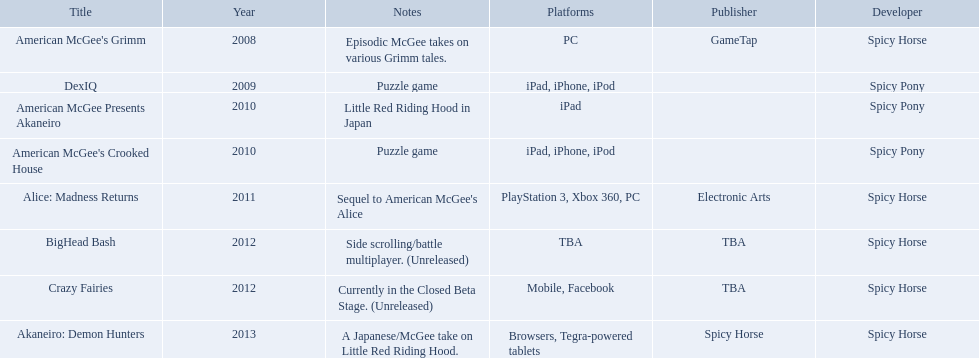Which spicy horse titles are shown? American McGee's Grimm, DexIQ, American McGee Presents Akaneiro, American McGee's Crooked House, Alice: Madness Returns, BigHead Bash, Crazy Fairies, Akaneiro: Demon Hunters. Of those, which are for the ipad? DexIQ, American McGee Presents Akaneiro, American McGee's Crooked House. Which of those are not for the iphone or ipod? American McGee Presents Akaneiro. 